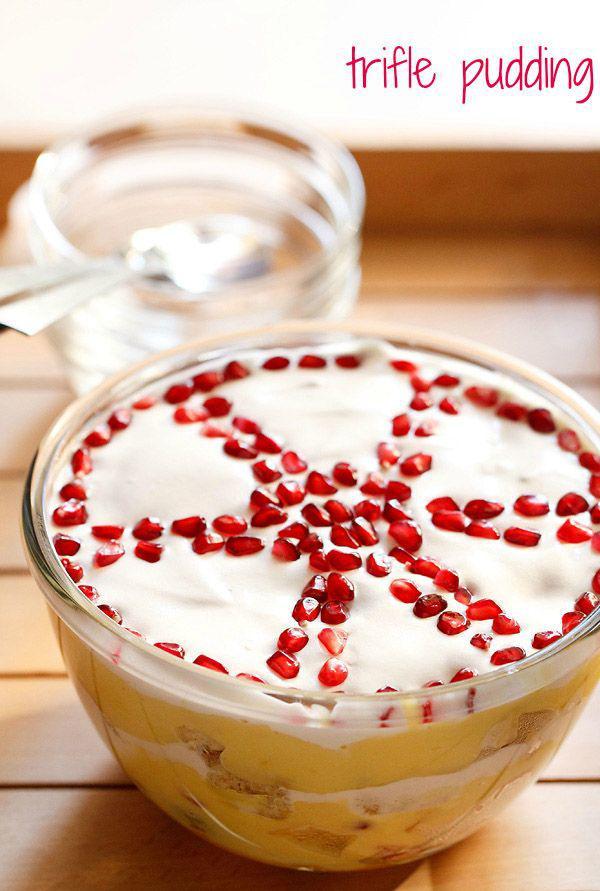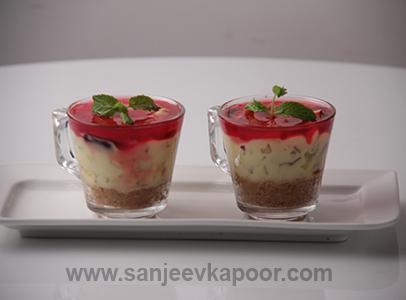The first image is the image on the left, the second image is the image on the right. Examine the images to the left and right. Is the description "There are spoons near a dessert." accurate? Answer yes or no. No. 